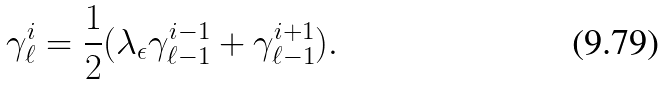<formula> <loc_0><loc_0><loc_500><loc_500>\gamma _ { \ell } ^ { i } = \frac { 1 } { 2 } ( \lambda _ { \epsilon } \gamma _ { \ell - 1 } ^ { i - 1 } + \gamma _ { \ell - 1 } ^ { i + 1 } ) .</formula> 